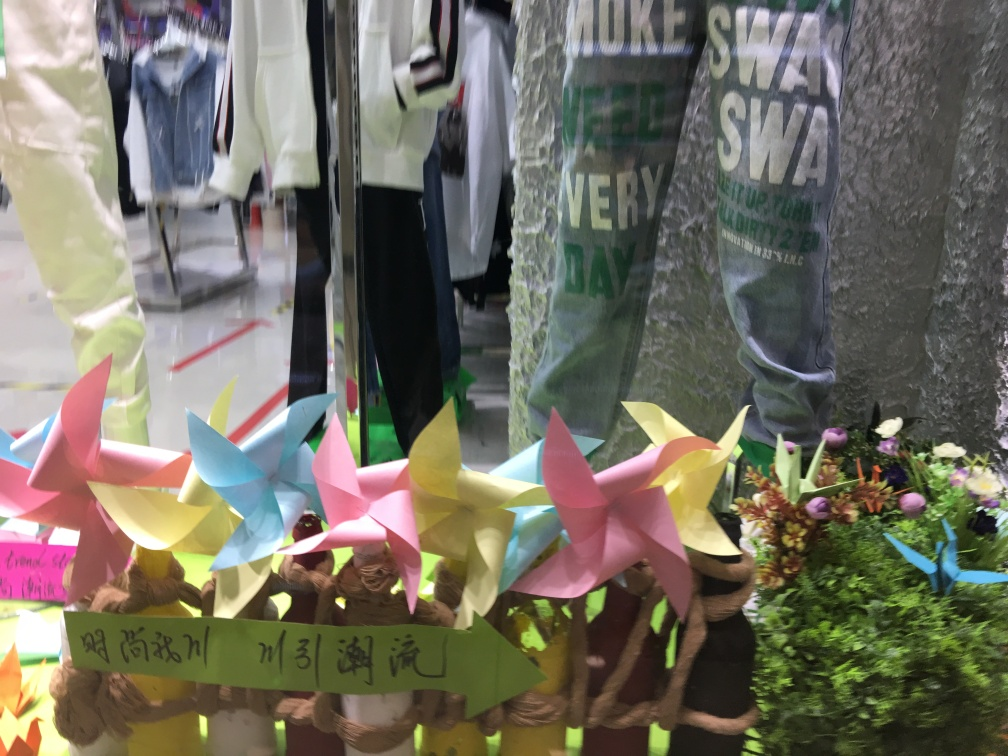Can you describe the mood or atmosphere this image conveys? The image conveys a vibrant and lively ambiance through the use of bright colors and varied textures. The playful arrangement of the pinwheels and the casual style of clothing suggest a setting that is youthful and energetic. The natural elements, like the flowers, add a touch of freshness and hint at a spring or festive season in a retail or possibly a craft market environment. 